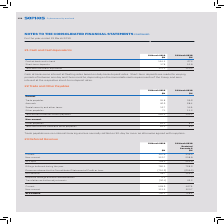According to Sophos Group's financial document, What are the conditions for trade payables? Trade payables are non interest-bearing and are normally settled on 30-day terms or as otherwise agreed with suppliers.. The document states: "Trade payables are non interest-bearing and are normally settled on 30-day terms or as otherwise agreed with suppliers...." Also, For which years are the trade and other payables calculated for? The document shows two values: 2019 and 2018. From the document: "31 March 2019 $M 31 March 2018 $M 31 March 2019 $M 31 March 2018 $M..." Also, What are the components which make up the total Current trade and other payables? The document contains multiple relevant values: Trade payables, Accruals, Social security and other taxes, Other payables. From the document: "Trade payables 35.8 39.6 Other payables 7.1 11.2 Accruals 46.6 68.4 Social security and other taxes 12.7 14.9..." Additionally, In which year was the amount of Total non-current trade and other payables larger? According to the financial document, 2019. The relevant text states: "31 March 2019 $M 31 March 2018 $M..." Also, can you calculate: What was the change in the Total non-current trade and other payables in 2019 from 2018? Based on the calculation: 10.1-8.2, the result is 1.9 (in millions). This is based on the information: "Other payables 10.1 8.2 Other payables 10.1 8.2..." The key data points involved are: 10.1, 8.2. Also, can you calculate: What was the percentage change in the Total non-current trade and other payables in 2019 from 2018? To answer this question, I need to perform calculations using the financial data. The calculation is: (10.1-8.2)/8.2, which equals 23.17 (percentage). This is based on the information: "Other payables 10.1 8.2 Other payables 10.1 8.2..." The key data points involved are: 10.1, 8.2. 